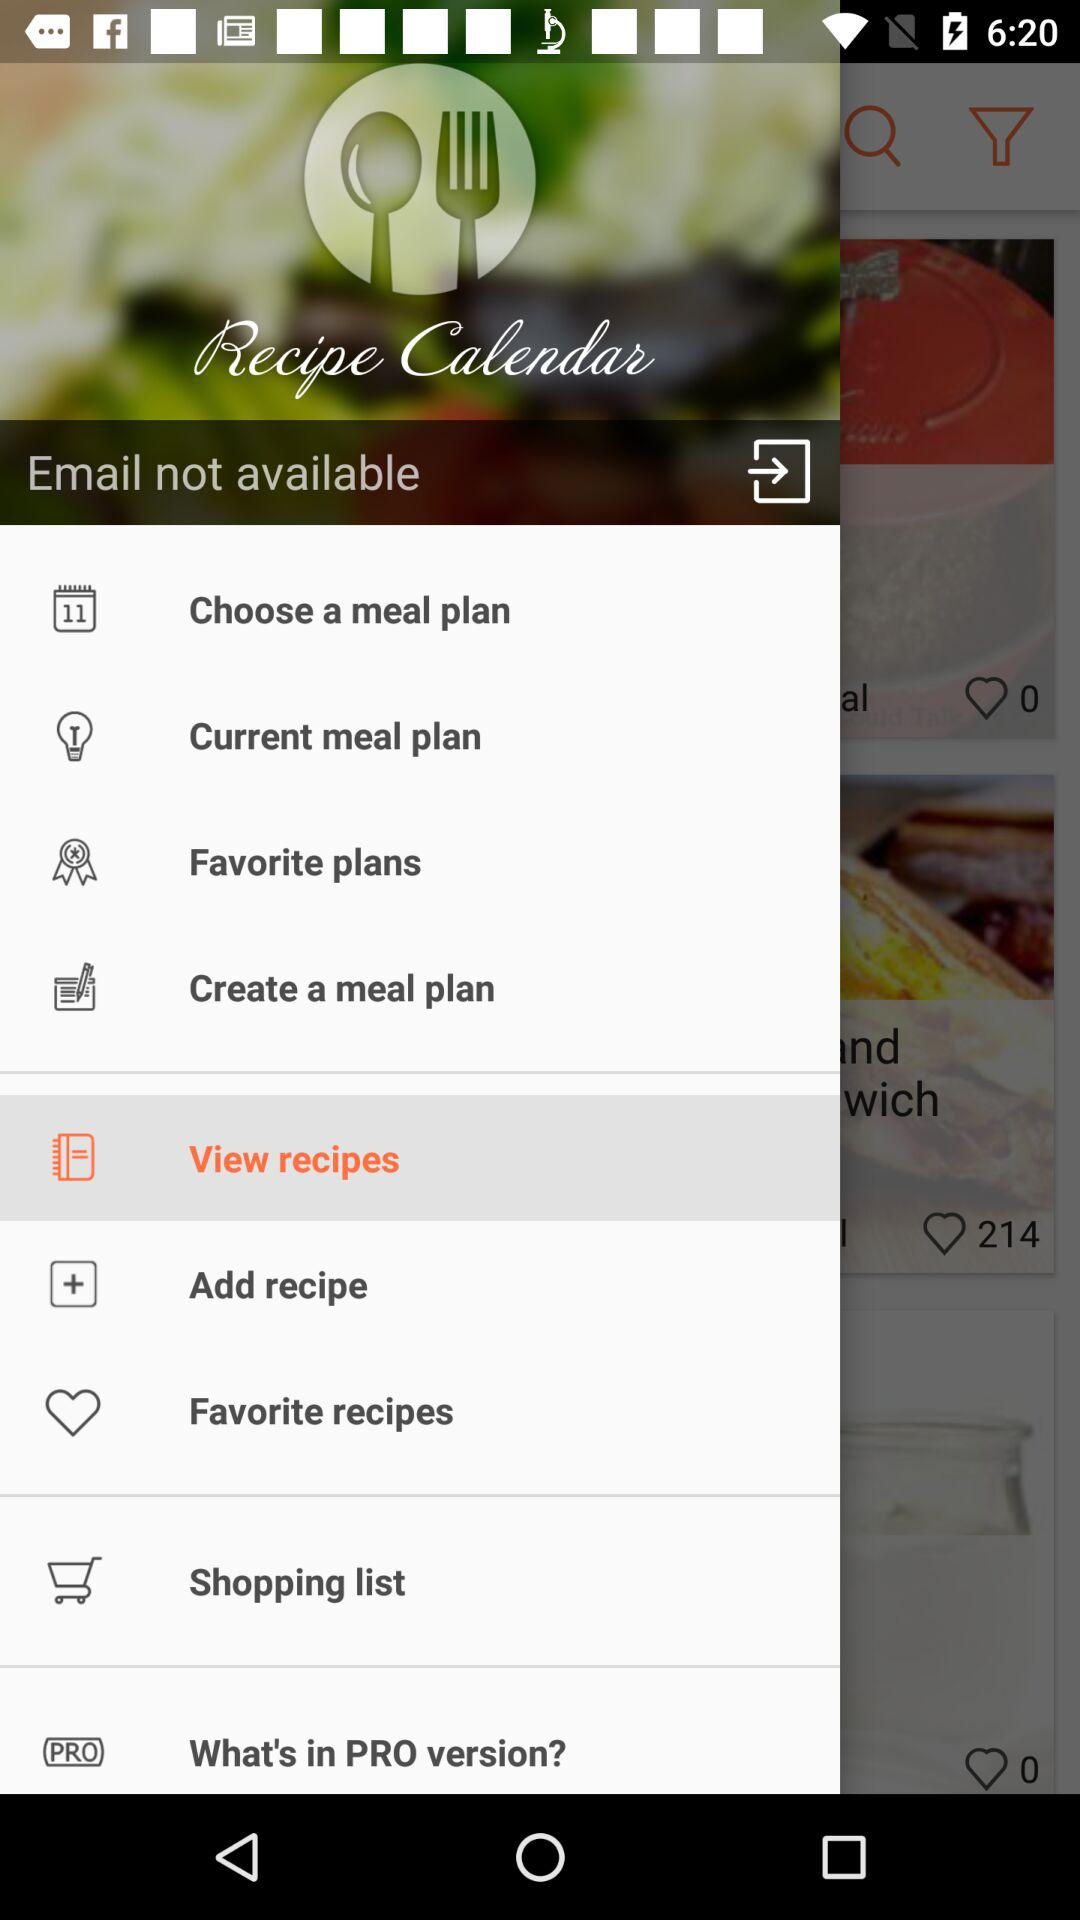What is the application name? The application name is "Recipe Calendar". 